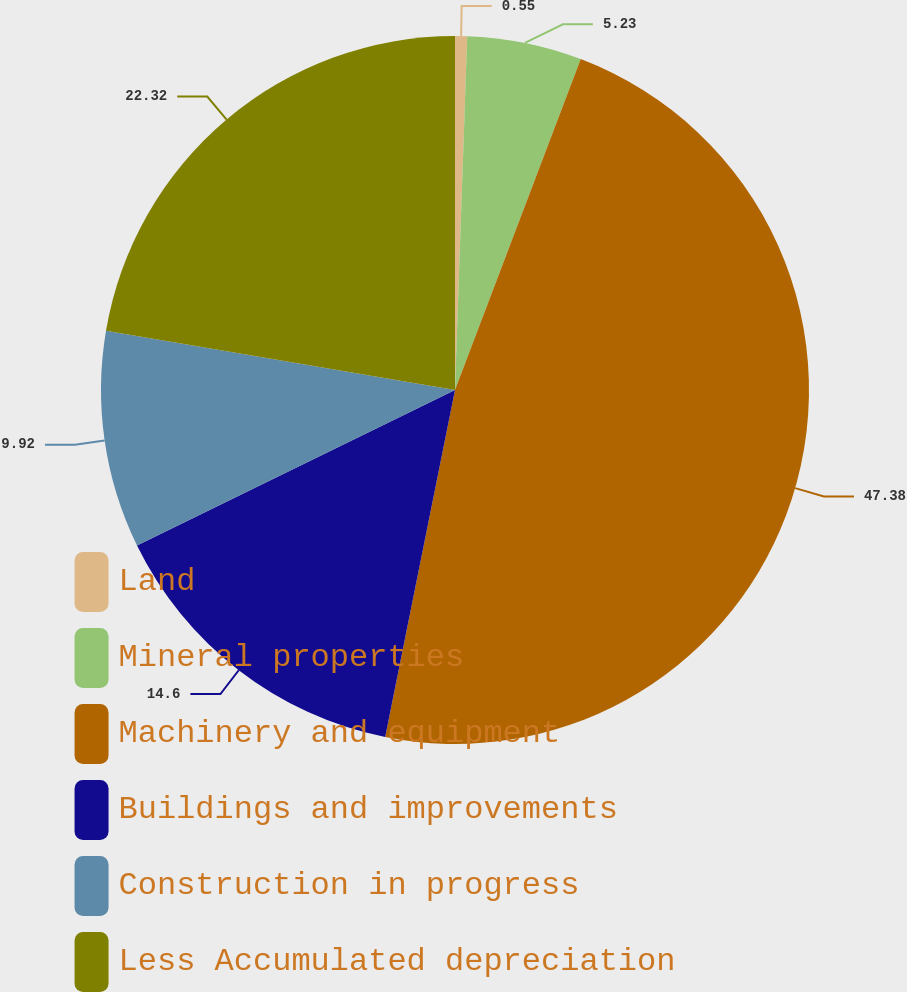Convert chart to OTSL. <chart><loc_0><loc_0><loc_500><loc_500><pie_chart><fcel>Land<fcel>Mineral properties<fcel>Machinery and equipment<fcel>Buildings and improvements<fcel>Construction in progress<fcel>Less Accumulated depreciation<nl><fcel>0.55%<fcel>5.23%<fcel>47.38%<fcel>14.6%<fcel>9.92%<fcel>22.32%<nl></chart> 